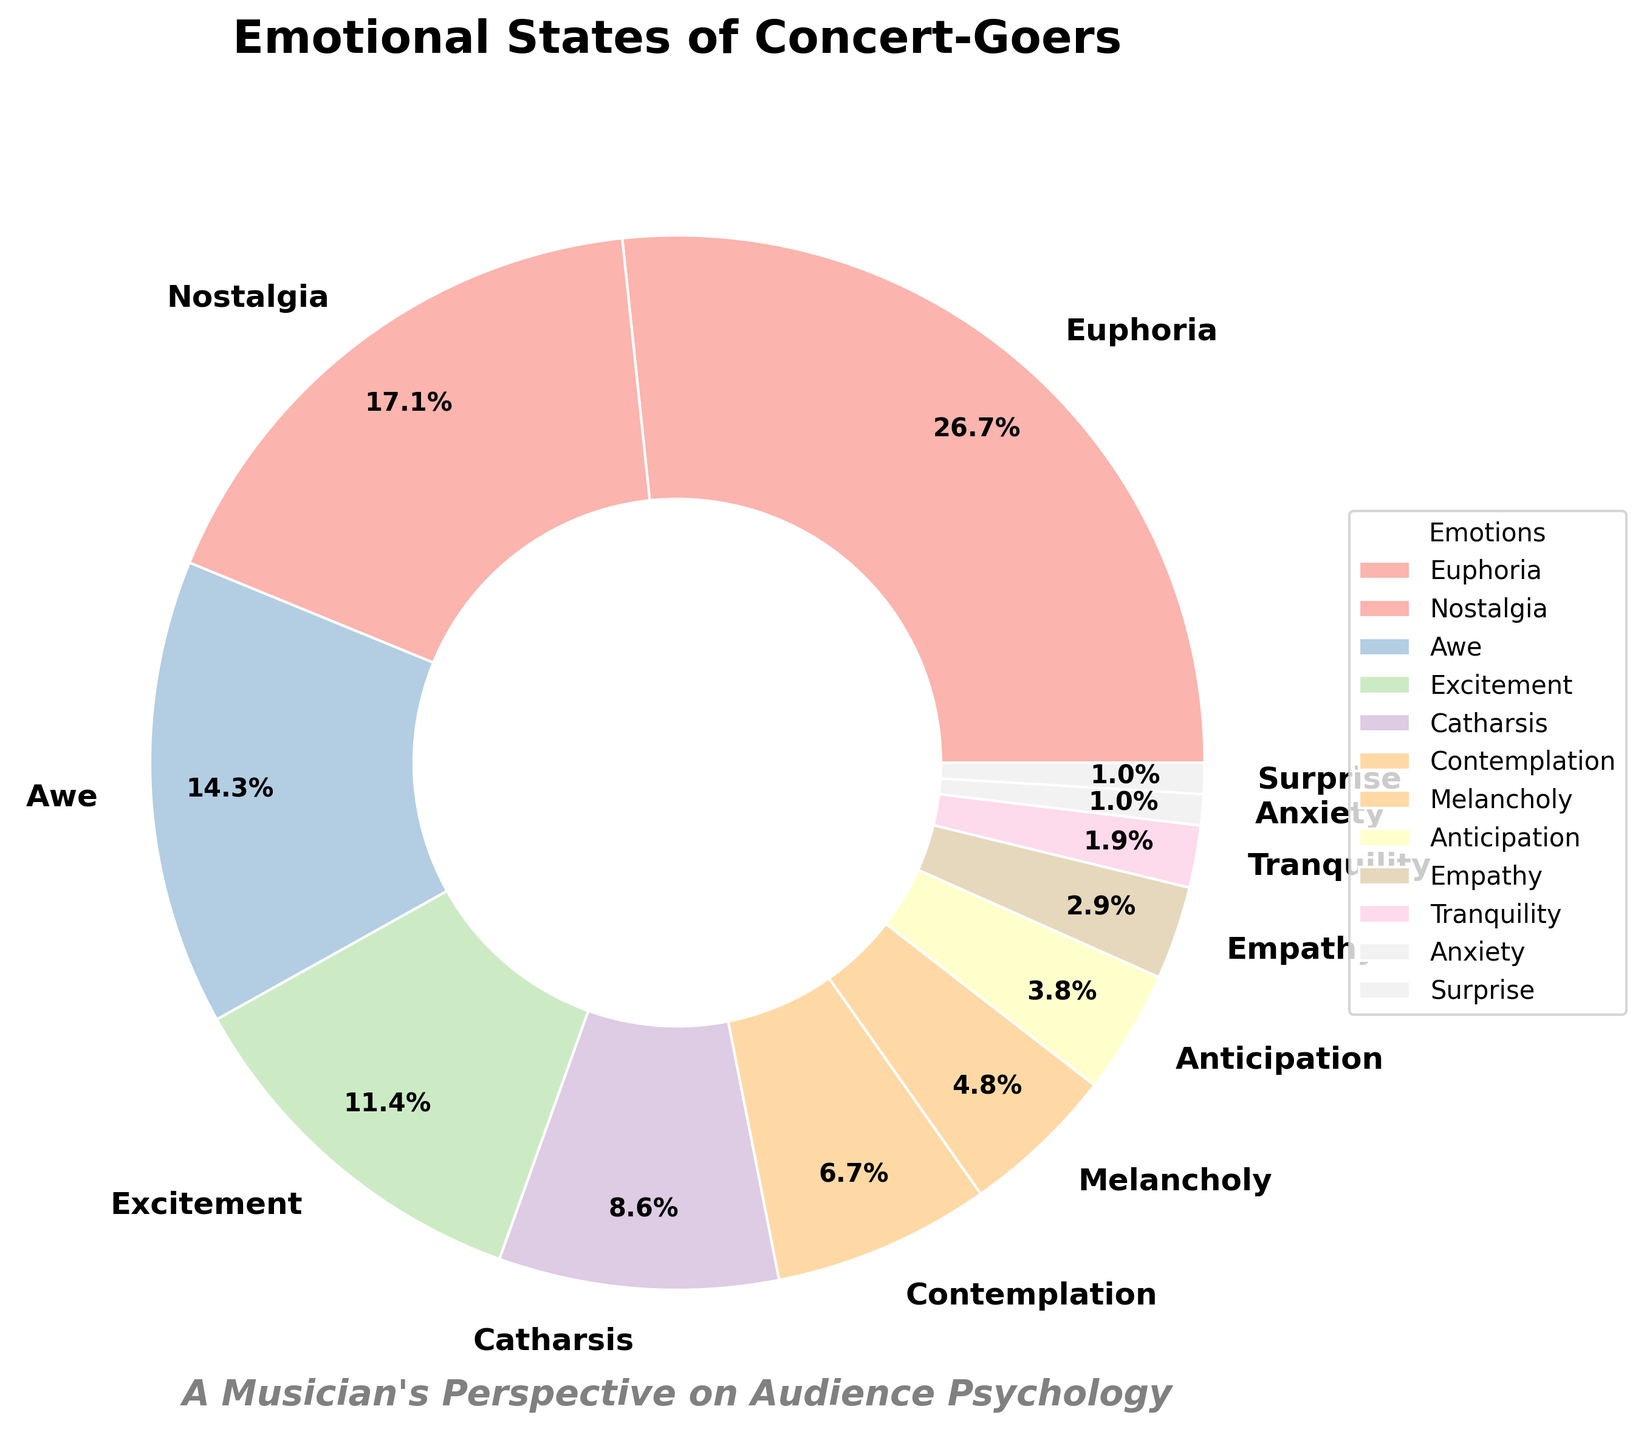Which emotion is the most commonly experienced by concert-goers? The figure shows that the largest segment of the pie chart is labeled "Euphoria" with a corresponding percentage. This indicates it is the most commonly experienced emotion.
Answer: Euphoria How does the percentage of people experiencing "Nostalgia" compare to those experiencing "Anticipation"? Based on the figure, "Nostalgia" is 18% and "Anticipation" is 4%. By comparing these two values, "Nostalgia" is significantly higher.
Answer: Nostalgia is higher What is the combined percentage of concert-goers experiencing "Catharsis" and "Contemplation"? By adding the percentages of "Catharsis" (9%) and "Contemplation" (7%), we get the combined percentage. Calculation: 9% + 7% = 16%
Answer: 16% Which emotions are experienced by less than 5% of concert-goers? By examining the pie chart and looking at the segments with percentages less than 5%, we find "Anticipation" (4%), "Empathy" (3%), "Tranquility" (2%), "Anxiety" (1%), and "Surprise" (1%).
Answer: Anticipation, Empathy, Tranquility, Anxiety, Surprise What is the difference between the percentage of people experiencing "Euphoria" and "Melancholy"? By subtracting the percentage of "Melancholy" (5%) from "Euphoria" (28%), we get the difference. Calculation: 28% - 5% = 23%
Answer: 23% How much more common is "Excitement" compared to "Anxiety"? According to the figure, "Excitement" is 12% and "Anxiety" is 1%. The difference is calculated as 12% - 1% = 11%. Therefore, "Excitement" is 11% more common than "Anxiety".
Answer: 11% What is the total percentage of concert-goers experiencing any of the top three most common emotions? The top three most common emotions are "Euphoria" (28%), "Nostalgia" (18%), and "Awe" (15%). Adding these gives the total percentage. Calculation: 28% + 18% + 15% = 61%
Answer: 61% Which emotion occupies the smallest section of the pie chart? By looking for the smallest segment on the pie chart, we can determine that both "Anxiety" and "Surprise" each occupy 1% of the pie chart.
Answer: Anxiety and Surprise 